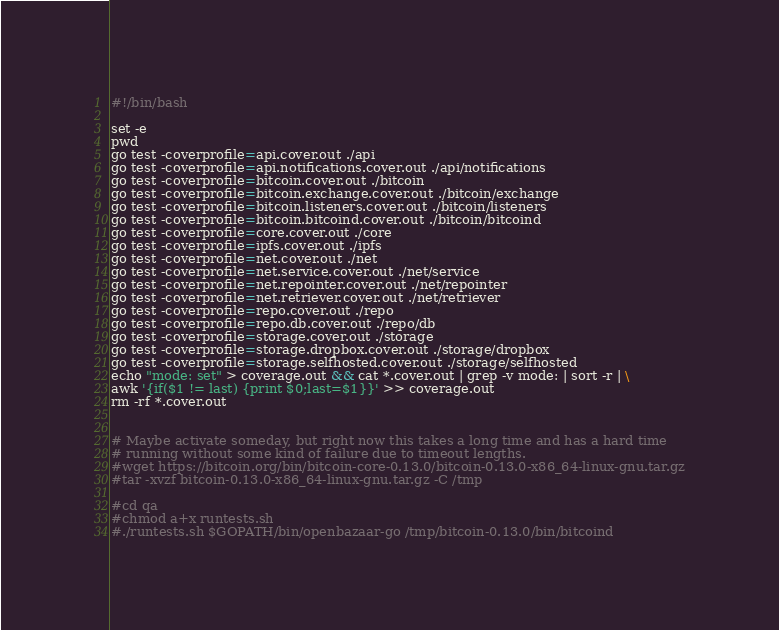Convert code to text. <code><loc_0><loc_0><loc_500><loc_500><_Bash_>#!/bin/bash

set -e
pwd
go test -coverprofile=api.cover.out ./api
go test -coverprofile=api.notifications.cover.out ./api/notifications
go test -coverprofile=bitcoin.cover.out ./bitcoin
go test -coverprofile=bitcoin.exchange.cover.out ./bitcoin/exchange
go test -coverprofile=bitcoin.listeners.cover.out ./bitcoin/listeners
go test -coverprofile=bitcoin.bitcoind.cover.out ./bitcoin/bitcoind
go test -coverprofile=core.cover.out ./core
go test -coverprofile=ipfs.cover.out ./ipfs
go test -coverprofile=net.cover.out ./net
go test -coverprofile=net.service.cover.out ./net/service
go test -coverprofile=net.repointer.cover.out ./net/repointer
go test -coverprofile=net.retriever.cover.out ./net/retriever
go test -coverprofile=repo.cover.out ./repo
go test -coverprofile=repo.db.cover.out ./repo/db
go test -coverprofile=storage.cover.out ./storage
go test -coverprofile=storage.dropbox.cover.out ./storage/dropbox
go test -coverprofile=storage.selfhosted.cover.out ./storage/selfhosted
echo "mode: set" > coverage.out && cat *.cover.out | grep -v mode: | sort -r | \
awk '{if($1 != last) {print $0;last=$1}}' >> coverage.out
rm -rf *.cover.out


# Maybe activate someday, but right now this takes a long time and has a hard time
# running without some kind of failure due to timeout lengths.
#wget https://bitcoin.org/bin/bitcoin-core-0.13.0/bitcoin-0.13.0-x86_64-linux-gnu.tar.gz
#tar -xvzf bitcoin-0.13.0-x86_64-linux-gnu.tar.gz -C /tmp

#cd qa
#chmod a+x runtests.sh
#./runtests.sh $GOPATH/bin/openbazaar-go /tmp/bitcoin-0.13.0/bin/bitcoind</code> 